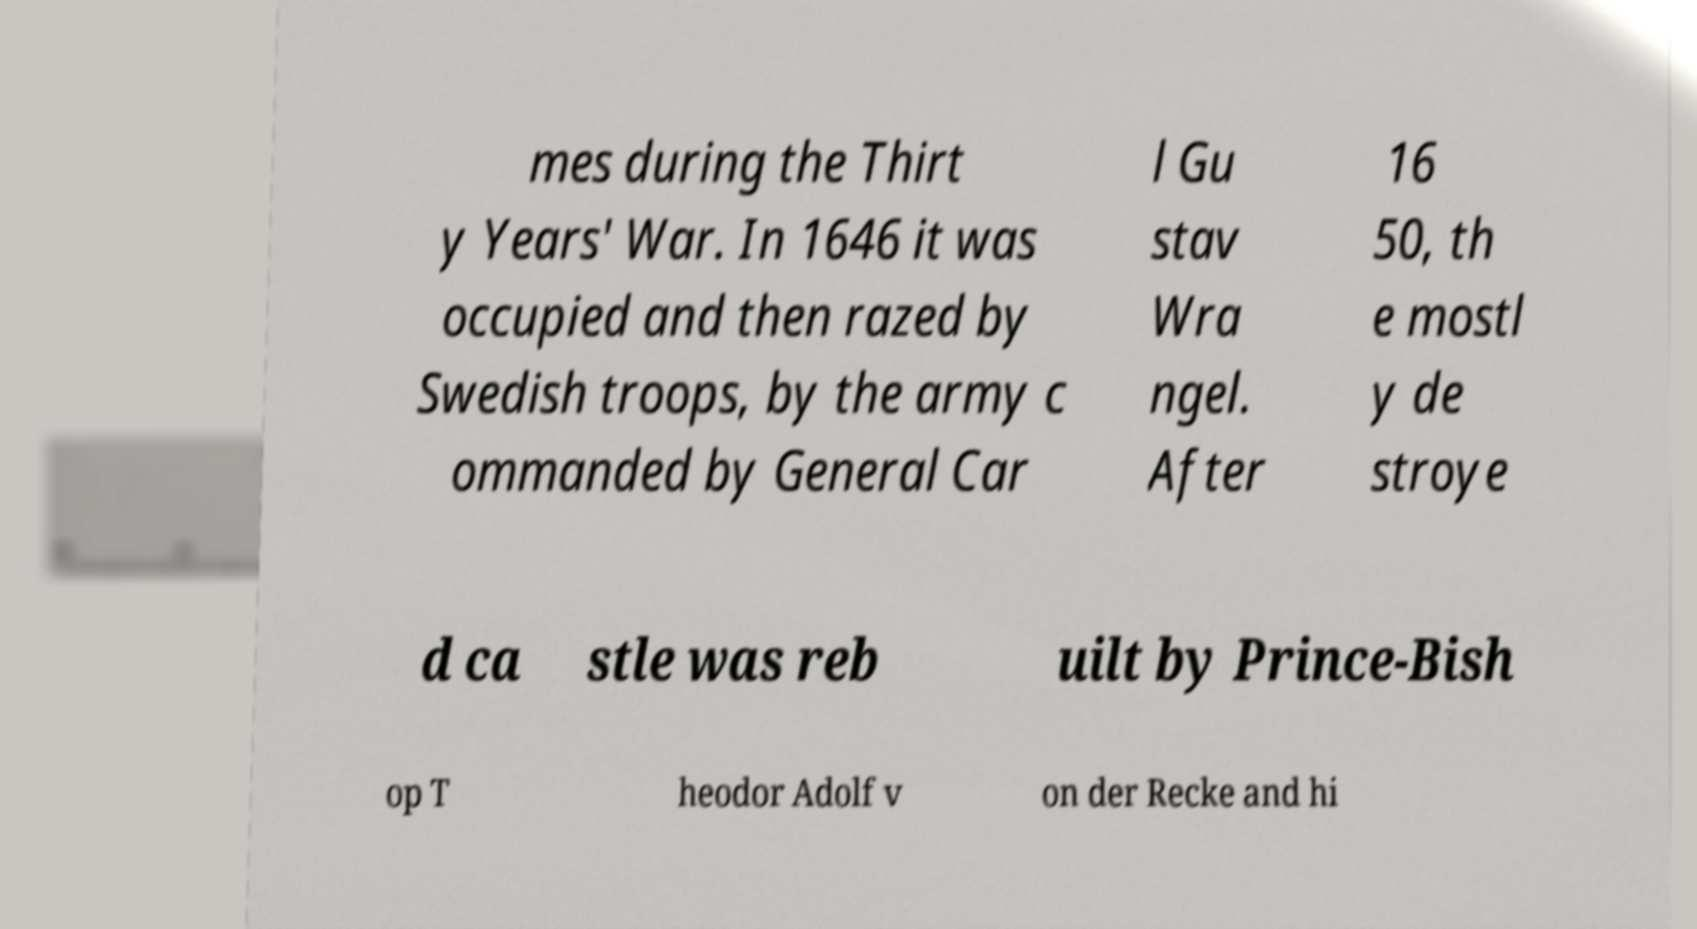What messages or text are displayed in this image? I need them in a readable, typed format. mes during the Thirt y Years' War. In 1646 it was occupied and then razed by Swedish troops, by the army c ommanded by General Car l Gu stav Wra ngel. After 16 50, th e mostl y de stroye d ca stle was reb uilt by Prince-Bish op T heodor Adolf v on der Recke and hi 